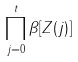Convert formula to latex. <formula><loc_0><loc_0><loc_500><loc_500>\prod _ { j = 0 } ^ { t } \beta [ Z ( j ) ]</formula> 